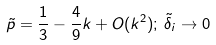Convert formula to latex. <formula><loc_0><loc_0><loc_500><loc_500>\tilde { p } = \frac { 1 } { 3 } - \frac { 4 } { 9 } k + O ( k ^ { 2 } ) ; \, \tilde { \delta } _ { i } \rightarrow 0</formula> 